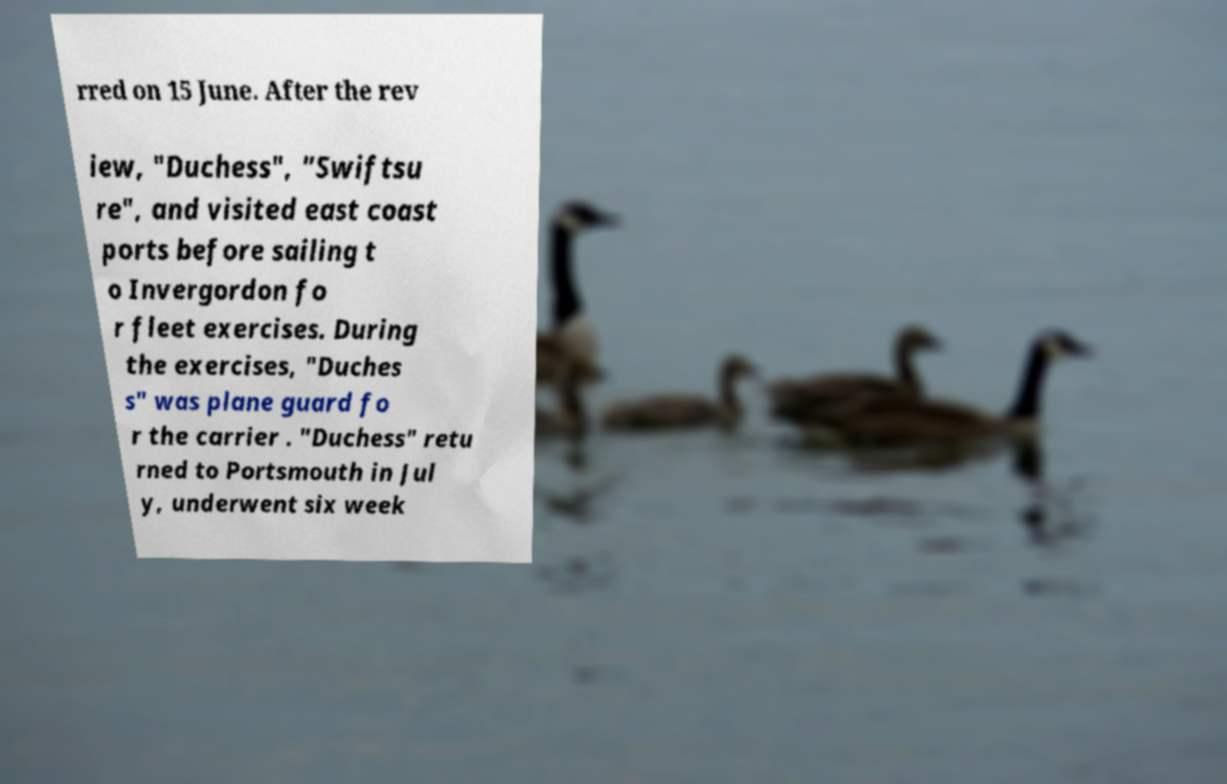For documentation purposes, I need the text within this image transcribed. Could you provide that? rred on 15 June. After the rev iew, "Duchess", "Swiftsu re", and visited east coast ports before sailing t o Invergordon fo r fleet exercises. During the exercises, "Duches s" was plane guard fo r the carrier . "Duchess" retu rned to Portsmouth in Jul y, underwent six week 